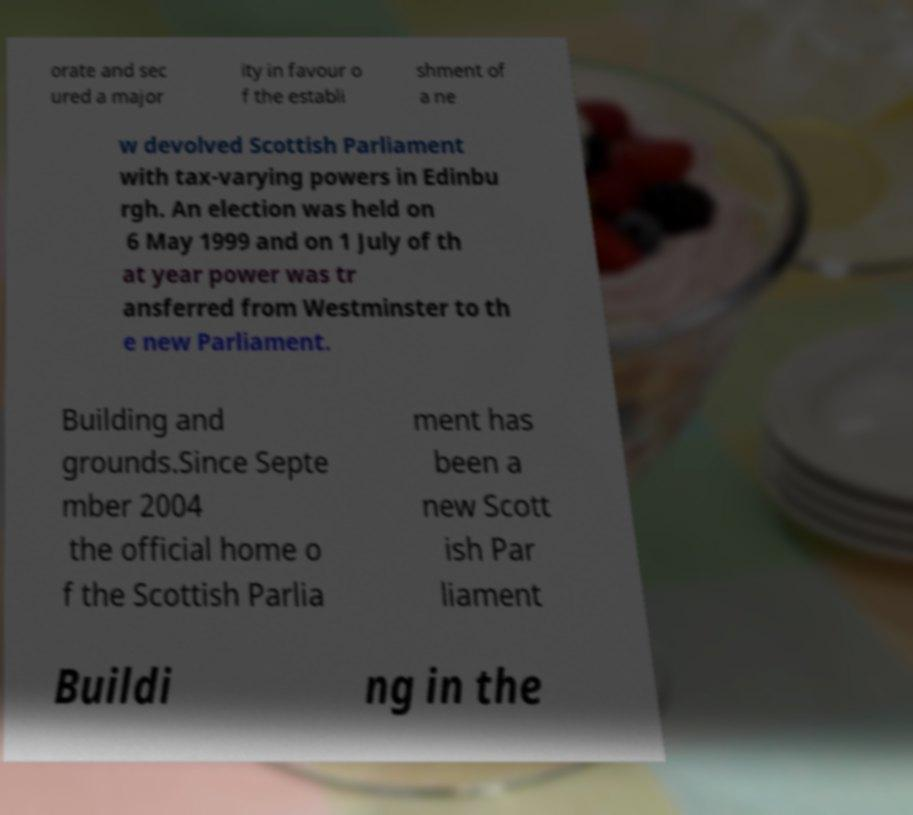Could you assist in decoding the text presented in this image and type it out clearly? orate and sec ured a major ity in favour o f the establi shment of a ne w devolved Scottish Parliament with tax-varying powers in Edinbu rgh. An election was held on 6 May 1999 and on 1 July of th at year power was tr ansferred from Westminster to th e new Parliament. Building and grounds.Since Septe mber 2004 the official home o f the Scottish Parlia ment has been a new Scott ish Par liament Buildi ng in the 